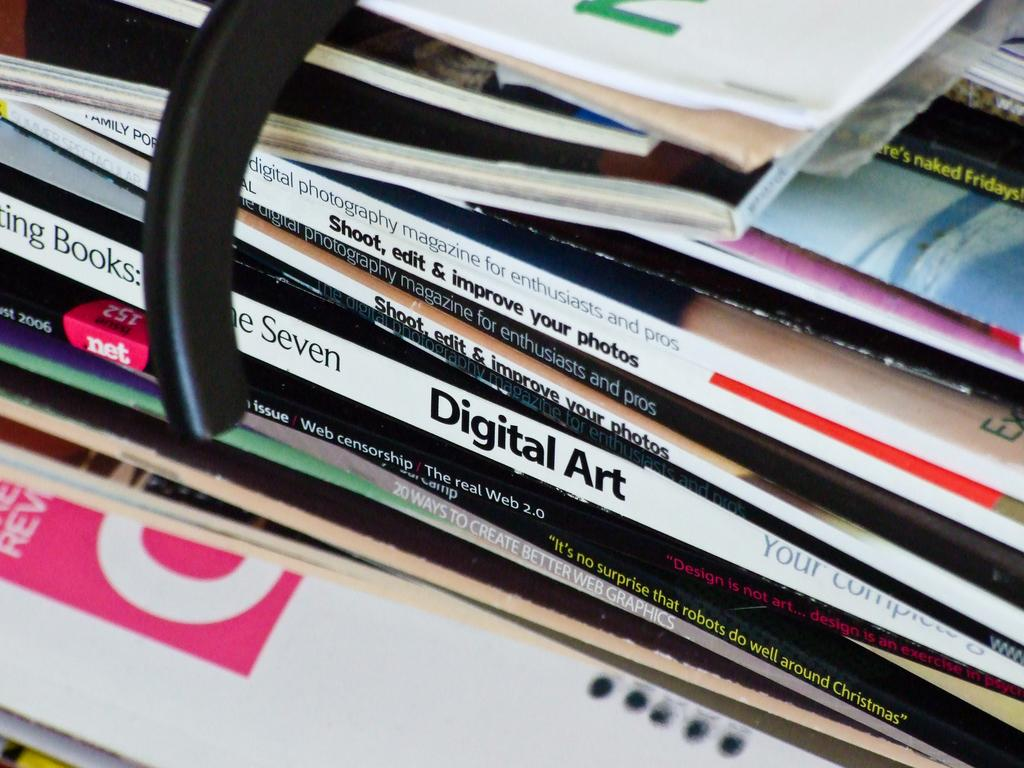<image>
Render a clear and concise summary of the photo. several magazines in a pile including Digital Art 